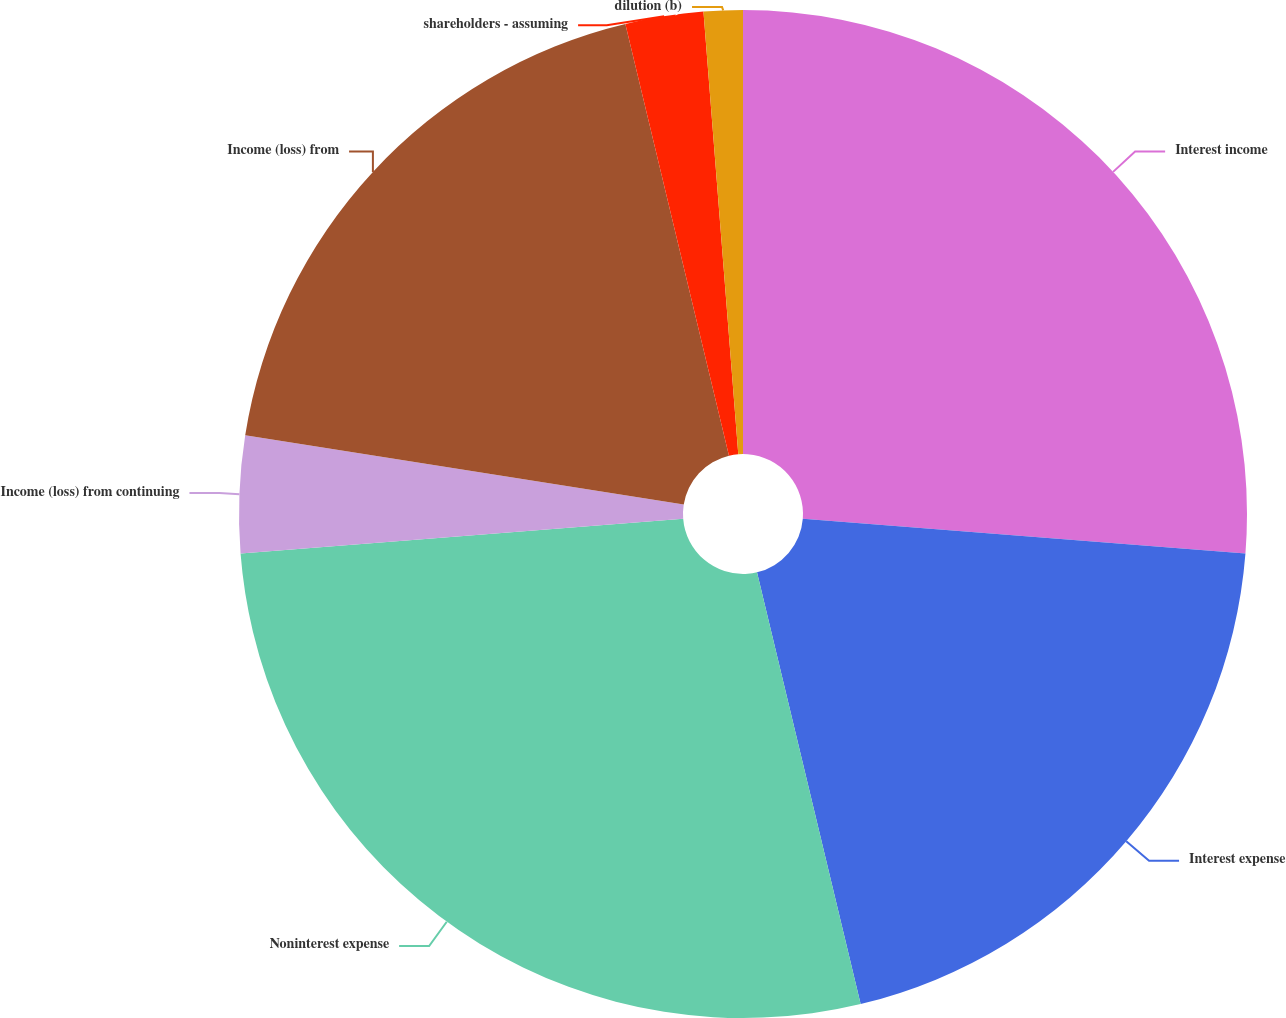<chart> <loc_0><loc_0><loc_500><loc_500><pie_chart><fcel>Interest income<fcel>Interest expense<fcel>Noninterest expense<fcel>Income (loss) from continuing<fcel>Income (loss) from<fcel>shareholders - assuming<fcel>dilution (b)<nl><fcel>26.25%<fcel>20.0%<fcel>27.5%<fcel>3.75%<fcel>18.75%<fcel>2.5%<fcel>1.25%<nl></chart> 